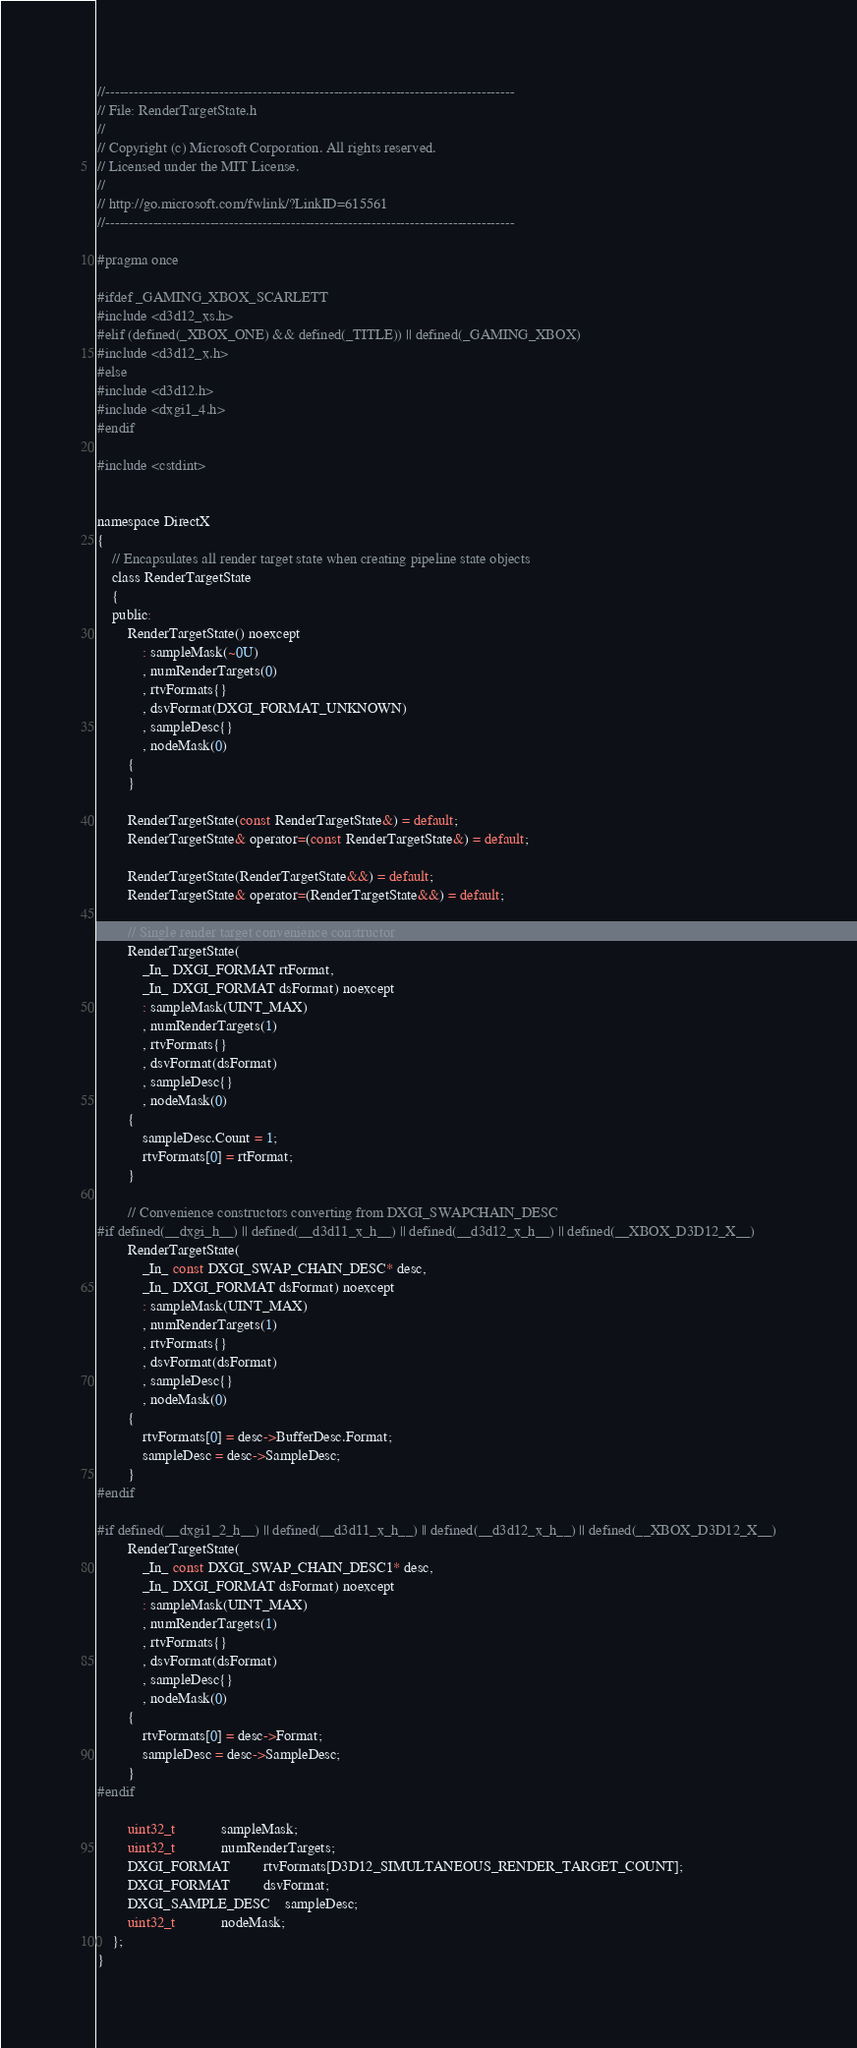Convert code to text. <code><loc_0><loc_0><loc_500><loc_500><_C_>//--------------------------------------------------------------------------------------
// File: RenderTargetState.h
//
// Copyright (c) Microsoft Corporation. All rights reserved.
// Licensed under the MIT License.
//
// http://go.microsoft.com/fwlink/?LinkID=615561
//--------------------------------------------------------------------------------------

#pragma once

#ifdef _GAMING_XBOX_SCARLETT
#include <d3d12_xs.h>
#elif (defined(_XBOX_ONE) && defined(_TITLE)) || defined(_GAMING_XBOX)
#include <d3d12_x.h>
#else
#include <d3d12.h>
#include <dxgi1_4.h>
#endif

#include <cstdint>


namespace DirectX
{
    // Encapsulates all render target state when creating pipeline state objects
    class RenderTargetState
    {
    public:
        RenderTargetState() noexcept
            : sampleMask(~0U)
            , numRenderTargets(0)
            , rtvFormats{}
            , dsvFormat(DXGI_FORMAT_UNKNOWN)
            , sampleDesc{}
            , nodeMask(0)
        {
        }

        RenderTargetState(const RenderTargetState&) = default;
        RenderTargetState& operator=(const RenderTargetState&) = default;

        RenderTargetState(RenderTargetState&&) = default;
        RenderTargetState& operator=(RenderTargetState&&) = default;

        // Single render target convenience constructor
        RenderTargetState(
            _In_ DXGI_FORMAT rtFormat,
            _In_ DXGI_FORMAT dsFormat) noexcept
            : sampleMask(UINT_MAX)
            , numRenderTargets(1)
            , rtvFormats{}
            , dsvFormat(dsFormat)
            , sampleDesc{}
            , nodeMask(0)
        {
            sampleDesc.Count = 1;
            rtvFormats[0] = rtFormat;
        }

        // Convenience constructors converting from DXGI_SWAPCHAIN_DESC
#if defined(__dxgi_h__) || defined(__d3d11_x_h__) || defined(__d3d12_x_h__) || defined(__XBOX_D3D12_X__)
        RenderTargetState(
            _In_ const DXGI_SWAP_CHAIN_DESC* desc,
            _In_ DXGI_FORMAT dsFormat) noexcept
            : sampleMask(UINT_MAX)
            , numRenderTargets(1)
            , rtvFormats{}
            , dsvFormat(dsFormat)
            , sampleDesc{}
            , nodeMask(0)
        {
            rtvFormats[0] = desc->BufferDesc.Format;
            sampleDesc = desc->SampleDesc;
        }
#endif

#if defined(__dxgi1_2_h__) || defined(__d3d11_x_h__) || defined(__d3d12_x_h__) || defined(__XBOX_D3D12_X__)
        RenderTargetState(
            _In_ const DXGI_SWAP_CHAIN_DESC1* desc,
            _In_ DXGI_FORMAT dsFormat) noexcept
            : sampleMask(UINT_MAX)
            , numRenderTargets(1)
            , rtvFormats{}
            , dsvFormat(dsFormat)
            , sampleDesc{}
            , nodeMask(0)
        {
            rtvFormats[0] = desc->Format;
            sampleDesc = desc->SampleDesc;
        }
#endif

        uint32_t            sampleMask;
        uint32_t            numRenderTargets;
        DXGI_FORMAT         rtvFormats[D3D12_SIMULTANEOUS_RENDER_TARGET_COUNT];
        DXGI_FORMAT         dsvFormat;
        DXGI_SAMPLE_DESC    sampleDesc;
        uint32_t            nodeMask;
    };
}
</code> 